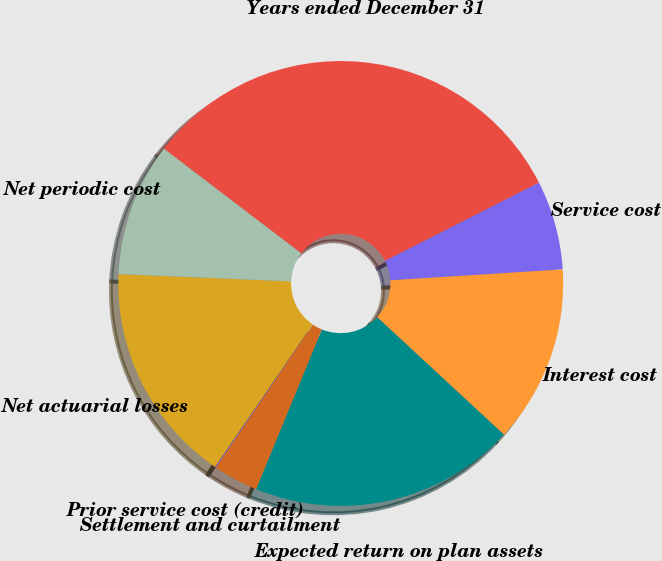<chart> <loc_0><loc_0><loc_500><loc_500><pie_chart><fcel>Years ended December 31<fcel>Service cost<fcel>Interest cost<fcel>Expected return on plan assets<fcel>Settlement and curtailment<fcel>Prior service cost (credit)<fcel>Net actuarial losses<fcel>Net periodic cost<nl><fcel>32.15%<fcel>6.48%<fcel>12.9%<fcel>19.32%<fcel>3.28%<fcel>0.07%<fcel>16.11%<fcel>9.69%<nl></chart> 